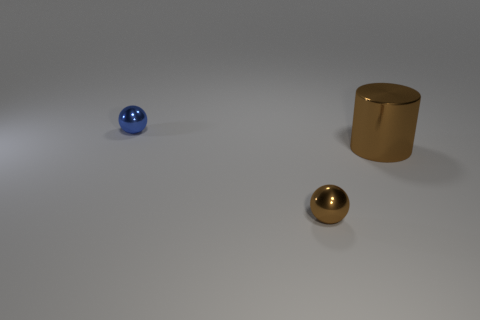Subtract all purple spheres. Subtract all green cubes. How many spheres are left? 2 Add 3 large brown cylinders. How many objects exist? 6 Subtract all cylinders. How many objects are left? 2 Subtract all cylinders. Subtract all small balls. How many objects are left? 0 Add 1 balls. How many balls are left? 3 Add 2 large shiny things. How many large shiny things exist? 3 Subtract 0 purple balls. How many objects are left? 3 